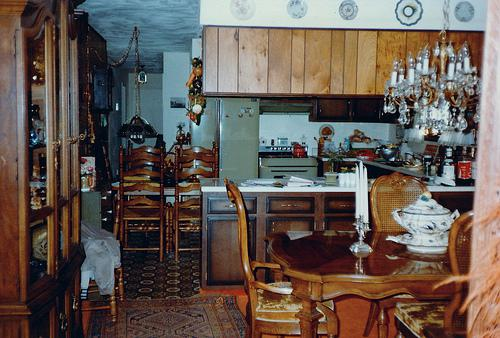Question: where are is the refrigerator?
Choices:
A. In the kitchen.
B. In the dining room.
C. In the store.
D. In the storage.
Answer with the letter. Answer: A Question: what color is the refrigerator?
Choices:
A. White.
B. Green.
C. Silver.
D. Black.
Answer with the letter. Answer: B Question: what is the table made of?
Choices:
A. Metal.
B. Plastic.
C. Glass.
D. Wood.
Answer with the letter. Answer: D Question: how many chairs are there?
Choices:
A. Five.
B. Four.
C. Three.
D. Six.
Answer with the letter. Answer: A 